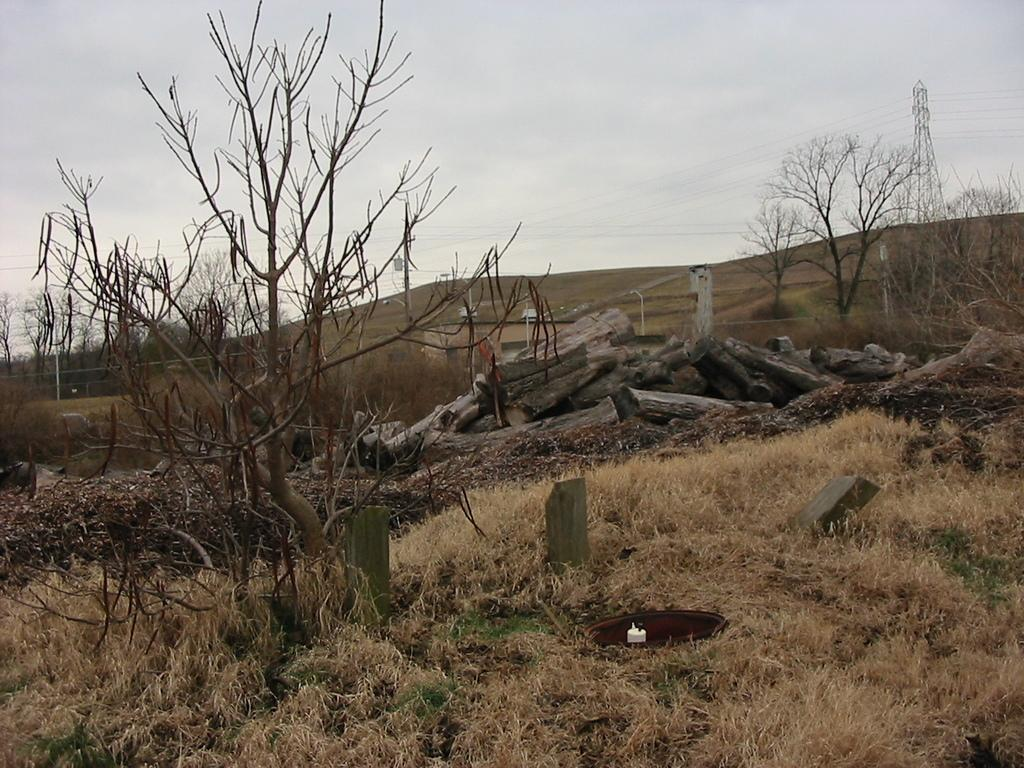What type of vegetation can be seen in the image? There is grass in the image. What other objects can be seen on the ground? There are stones and a log of wood in the image. What can be seen in the background of the image? There are trees, wires, a tower, and the sky visible in the background of the image. Where is the lunchroom located in the image? There is no lunchroom present in the image. What type of bit is being used to interact with the trees in the image? There is no bit present in the image, and the trees are not being interacted with in any way. 